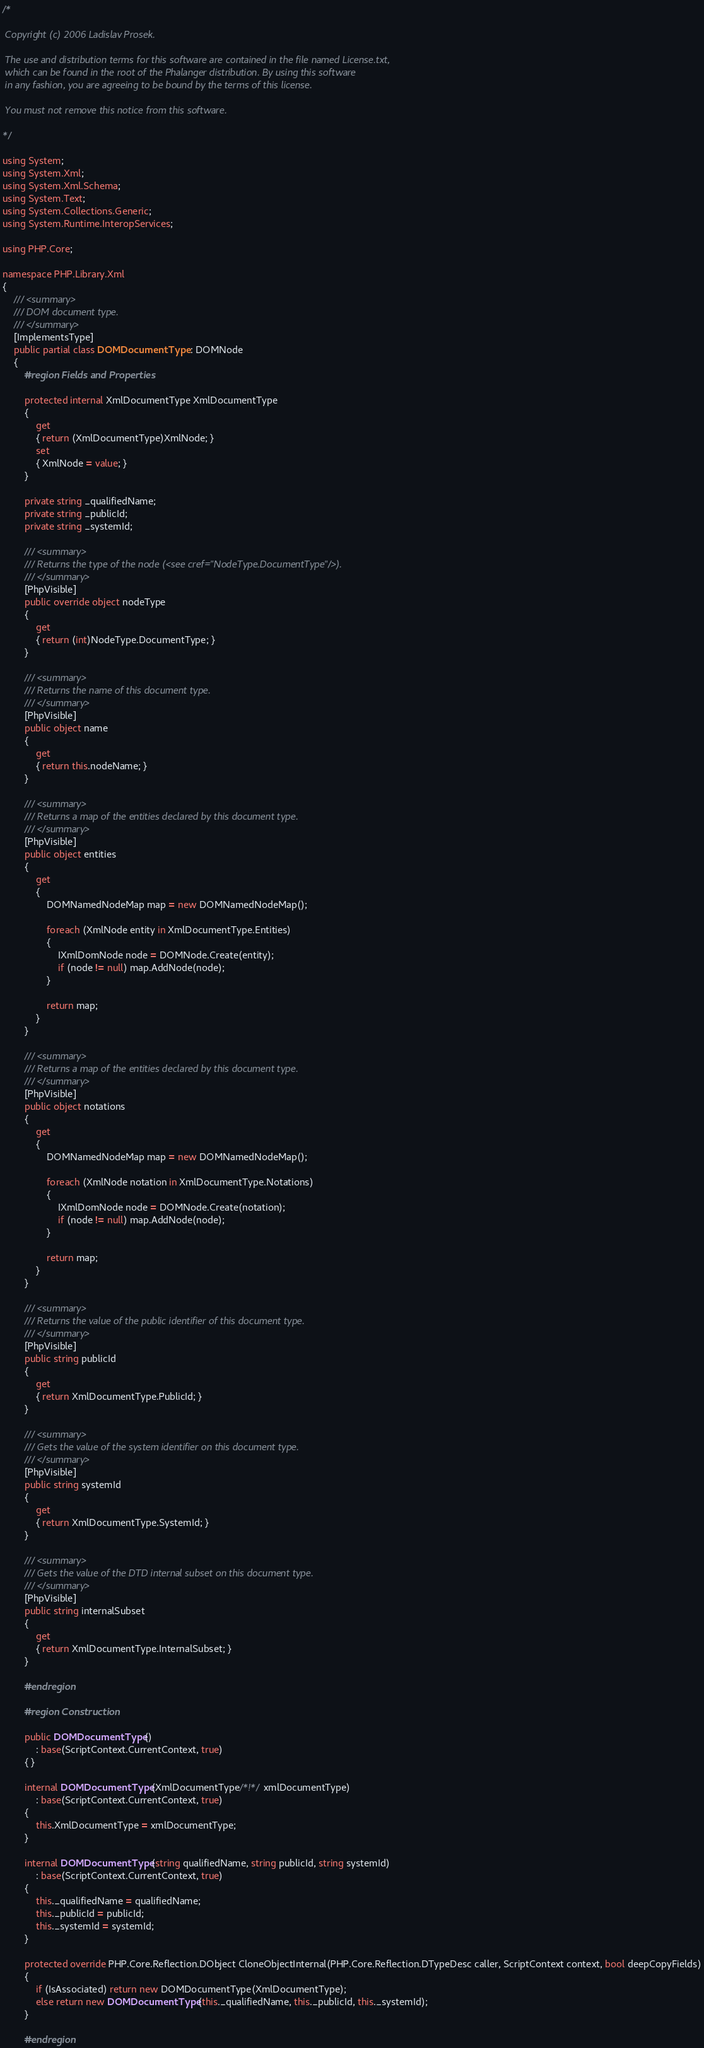Convert code to text. <code><loc_0><loc_0><loc_500><loc_500><_C#_>/*

 Copyright (c) 2006 Ladislav Prosek.  

 The use and distribution terms for this software are contained in the file named License.txt, 
 which can be found in the root of the Phalanger distribution. By using this software 
 in any fashion, you are agreeing to be bound by the terms of this license.
 
 You must not remove this notice from this software.

*/

using System;
using System.Xml;
using System.Xml.Schema;
using System.Text;
using System.Collections.Generic;
using System.Runtime.InteropServices;

using PHP.Core;

namespace PHP.Library.Xml
{
	/// <summary>
	/// DOM document type.
	/// </summary>
	[ImplementsType]
	public partial class DOMDocumentType : DOMNode
	{
		#region Fields and Properties

		protected internal XmlDocumentType XmlDocumentType
		{
			get
			{ return (XmlDocumentType)XmlNode; }
			set
			{ XmlNode = value; }
		}

		private string _qualifiedName;
		private string _publicId;
		private string _systemId;

		/// <summary>
		/// Returns the type of the node (<see cref="NodeType.DocumentType"/>).
		/// </summary>
		[PhpVisible]
		public override object nodeType
		{
			get
			{ return (int)NodeType.DocumentType; }
		}

		/// <summary>
		/// Returns the name of this document type.
		/// </summary>
		[PhpVisible]
		public object name
		{
			get
			{ return this.nodeName; }
		}

		/// <summary>
		/// Returns a map of the entities declared by this document type.
		/// </summary>
		[PhpVisible]
		public object entities
		{
			get
			{
				DOMNamedNodeMap map = new DOMNamedNodeMap();

				foreach (XmlNode entity in XmlDocumentType.Entities)
				{
					IXmlDomNode node = DOMNode.Create(entity);
					if (node != null) map.AddNode(node);
				}

				return map;
			}
		}

		/// <summary>
		/// Returns a map of the entities declared by this document type.
		/// </summary>
		[PhpVisible]
		public object notations
		{
			get
			{
				DOMNamedNodeMap map = new DOMNamedNodeMap();

				foreach (XmlNode notation in XmlDocumentType.Notations)
				{
					IXmlDomNode node = DOMNode.Create(notation);
					if (node != null) map.AddNode(node);
				}

				return map;
			}
		}

		/// <summary>
		/// Returns the value of the public identifier of this document type.
		/// </summary>
		[PhpVisible]
		public string publicId
		{
			get
			{ return XmlDocumentType.PublicId; }
		}

		/// <summary>
		/// Gets the value of the system identifier on this document type.
		/// </summary>
		[PhpVisible]
		public string systemId
		{
			get
			{ return XmlDocumentType.SystemId; }
		}

		/// <summary>
		/// Gets the value of the DTD internal subset on this document type.
		/// </summary>
		[PhpVisible]
		public string internalSubset
		{
			get
			{ return XmlDocumentType.InternalSubset; }
		}

		#endregion

		#region Construction

		public DOMDocumentType()
			: base(ScriptContext.CurrentContext, true)
		{ }

		internal DOMDocumentType(XmlDocumentType/*!*/ xmlDocumentType)
			: base(ScriptContext.CurrentContext, true)
		{
			this.XmlDocumentType = xmlDocumentType;
		}

		internal DOMDocumentType(string qualifiedName, string publicId, string systemId)
			: base(ScriptContext.CurrentContext, true)
		{
			this._qualifiedName = qualifiedName;
			this._publicId = publicId;
			this._systemId = systemId;
		}

		protected override PHP.Core.Reflection.DObject CloneObjectInternal(PHP.Core.Reflection.DTypeDesc caller, ScriptContext context, bool deepCopyFields)
		{
			if (IsAssociated) return new DOMDocumentType(XmlDocumentType);
			else return new DOMDocumentType(this._qualifiedName, this._publicId, this._systemId);
		}

		#endregion
</code> 